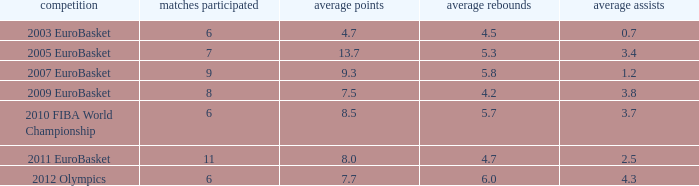How many assists per game have 4.2 rebounds per game? 3.8. 